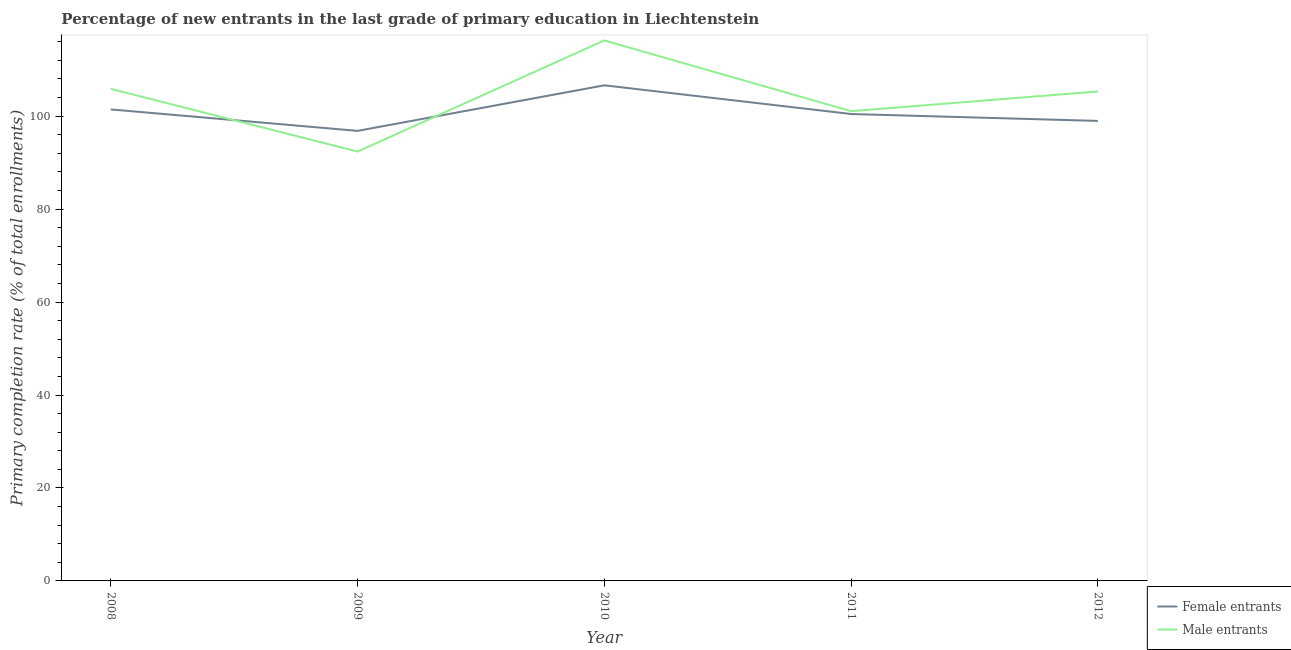What is the primary completion rate of female entrants in 2012?
Offer a very short reply. 98.97. Across all years, what is the maximum primary completion rate of male entrants?
Give a very brief answer. 116.29. Across all years, what is the minimum primary completion rate of male entrants?
Your response must be concise. 92.38. In which year was the primary completion rate of female entrants minimum?
Make the answer very short. 2009. What is the total primary completion rate of female entrants in the graph?
Offer a terse response. 504.35. What is the difference between the primary completion rate of female entrants in 2010 and that in 2011?
Offer a very short reply. 6.17. What is the difference between the primary completion rate of male entrants in 2009 and the primary completion rate of female entrants in 2008?
Offer a terse response. -9.07. What is the average primary completion rate of male entrants per year?
Ensure brevity in your answer.  104.19. In the year 2010, what is the difference between the primary completion rate of female entrants and primary completion rate of male entrants?
Your answer should be compact. -9.66. What is the ratio of the primary completion rate of male entrants in 2008 to that in 2010?
Provide a succinct answer. 0.91. What is the difference between the highest and the second highest primary completion rate of female entrants?
Keep it short and to the point. 5.19. What is the difference between the highest and the lowest primary completion rate of male entrants?
Offer a terse response. 23.92. In how many years, is the primary completion rate of female entrants greater than the average primary completion rate of female entrants taken over all years?
Provide a short and direct response. 2. Is the sum of the primary completion rate of female entrants in 2008 and 2012 greater than the maximum primary completion rate of male entrants across all years?
Your answer should be compact. Yes. Does the primary completion rate of female entrants monotonically increase over the years?
Give a very brief answer. No. How many lines are there?
Make the answer very short. 2. How many years are there in the graph?
Offer a very short reply. 5. What is the difference between two consecutive major ticks on the Y-axis?
Your answer should be very brief. 20. What is the title of the graph?
Your answer should be compact. Percentage of new entrants in the last grade of primary education in Liechtenstein. Does "Pregnant women" appear as one of the legend labels in the graph?
Provide a short and direct response. No. What is the label or title of the X-axis?
Keep it short and to the point. Year. What is the label or title of the Y-axis?
Your response must be concise. Primary completion rate (% of total enrollments). What is the Primary completion rate (% of total enrollments) of Female entrants in 2008?
Provide a short and direct response. 101.45. What is the Primary completion rate (% of total enrollments) in Male entrants in 2008?
Your answer should be compact. 105.88. What is the Primary completion rate (% of total enrollments) in Female entrants in 2009?
Offer a terse response. 96.83. What is the Primary completion rate (% of total enrollments) of Male entrants in 2009?
Ensure brevity in your answer.  92.38. What is the Primary completion rate (% of total enrollments) of Female entrants in 2010?
Keep it short and to the point. 106.64. What is the Primary completion rate (% of total enrollments) in Male entrants in 2010?
Your answer should be very brief. 116.29. What is the Primary completion rate (% of total enrollments) in Female entrants in 2011?
Offer a very short reply. 100.46. What is the Primary completion rate (% of total enrollments) of Male entrants in 2011?
Provide a short and direct response. 101.07. What is the Primary completion rate (% of total enrollments) in Female entrants in 2012?
Your answer should be compact. 98.97. What is the Primary completion rate (% of total enrollments) of Male entrants in 2012?
Provide a succinct answer. 105.31. Across all years, what is the maximum Primary completion rate (% of total enrollments) of Female entrants?
Your answer should be compact. 106.64. Across all years, what is the maximum Primary completion rate (% of total enrollments) of Male entrants?
Provide a succinct answer. 116.29. Across all years, what is the minimum Primary completion rate (% of total enrollments) of Female entrants?
Make the answer very short. 96.83. Across all years, what is the minimum Primary completion rate (% of total enrollments) in Male entrants?
Offer a terse response. 92.38. What is the total Primary completion rate (% of total enrollments) in Female entrants in the graph?
Provide a succinct answer. 504.35. What is the total Primary completion rate (% of total enrollments) in Male entrants in the graph?
Give a very brief answer. 520.93. What is the difference between the Primary completion rate (% of total enrollments) in Female entrants in 2008 and that in 2009?
Your response must be concise. 4.62. What is the difference between the Primary completion rate (% of total enrollments) in Male entrants in 2008 and that in 2009?
Your response must be concise. 13.51. What is the difference between the Primary completion rate (% of total enrollments) of Female entrants in 2008 and that in 2010?
Offer a very short reply. -5.19. What is the difference between the Primary completion rate (% of total enrollments) of Male entrants in 2008 and that in 2010?
Your answer should be very brief. -10.41. What is the difference between the Primary completion rate (% of total enrollments) in Female entrants in 2008 and that in 2011?
Your answer should be very brief. 0.99. What is the difference between the Primary completion rate (% of total enrollments) of Male entrants in 2008 and that in 2011?
Your answer should be very brief. 4.81. What is the difference between the Primary completion rate (% of total enrollments) of Female entrants in 2008 and that in 2012?
Make the answer very short. 2.47. What is the difference between the Primary completion rate (% of total enrollments) of Male entrants in 2008 and that in 2012?
Make the answer very short. 0.57. What is the difference between the Primary completion rate (% of total enrollments) in Female entrants in 2009 and that in 2010?
Keep it short and to the point. -9.8. What is the difference between the Primary completion rate (% of total enrollments) of Male entrants in 2009 and that in 2010?
Offer a terse response. -23.92. What is the difference between the Primary completion rate (% of total enrollments) in Female entrants in 2009 and that in 2011?
Your answer should be very brief. -3.63. What is the difference between the Primary completion rate (% of total enrollments) of Male entrants in 2009 and that in 2011?
Provide a succinct answer. -8.69. What is the difference between the Primary completion rate (% of total enrollments) in Female entrants in 2009 and that in 2012?
Your answer should be very brief. -2.14. What is the difference between the Primary completion rate (% of total enrollments) in Male entrants in 2009 and that in 2012?
Give a very brief answer. -12.94. What is the difference between the Primary completion rate (% of total enrollments) of Female entrants in 2010 and that in 2011?
Keep it short and to the point. 6.17. What is the difference between the Primary completion rate (% of total enrollments) of Male entrants in 2010 and that in 2011?
Ensure brevity in your answer.  15.22. What is the difference between the Primary completion rate (% of total enrollments) in Female entrants in 2010 and that in 2012?
Ensure brevity in your answer.  7.66. What is the difference between the Primary completion rate (% of total enrollments) in Male entrants in 2010 and that in 2012?
Make the answer very short. 10.98. What is the difference between the Primary completion rate (% of total enrollments) of Female entrants in 2011 and that in 2012?
Make the answer very short. 1.49. What is the difference between the Primary completion rate (% of total enrollments) of Male entrants in 2011 and that in 2012?
Ensure brevity in your answer.  -4.24. What is the difference between the Primary completion rate (% of total enrollments) in Female entrants in 2008 and the Primary completion rate (% of total enrollments) in Male entrants in 2009?
Provide a short and direct response. 9.07. What is the difference between the Primary completion rate (% of total enrollments) in Female entrants in 2008 and the Primary completion rate (% of total enrollments) in Male entrants in 2010?
Give a very brief answer. -14.84. What is the difference between the Primary completion rate (% of total enrollments) of Female entrants in 2008 and the Primary completion rate (% of total enrollments) of Male entrants in 2011?
Ensure brevity in your answer.  0.38. What is the difference between the Primary completion rate (% of total enrollments) in Female entrants in 2008 and the Primary completion rate (% of total enrollments) in Male entrants in 2012?
Your answer should be very brief. -3.86. What is the difference between the Primary completion rate (% of total enrollments) in Female entrants in 2009 and the Primary completion rate (% of total enrollments) in Male entrants in 2010?
Provide a succinct answer. -19.46. What is the difference between the Primary completion rate (% of total enrollments) in Female entrants in 2009 and the Primary completion rate (% of total enrollments) in Male entrants in 2011?
Offer a terse response. -4.24. What is the difference between the Primary completion rate (% of total enrollments) in Female entrants in 2009 and the Primary completion rate (% of total enrollments) in Male entrants in 2012?
Offer a terse response. -8.48. What is the difference between the Primary completion rate (% of total enrollments) of Female entrants in 2010 and the Primary completion rate (% of total enrollments) of Male entrants in 2011?
Give a very brief answer. 5.57. What is the difference between the Primary completion rate (% of total enrollments) of Female entrants in 2010 and the Primary completion rate (% of total enrollments) of Male entrants in 2012?
Ensure brevity in your answer.  1.32. What is the difference between the Primary completion rate (% of total enrollments) in Female entrants in 2011 and the Primary completion rate (% of total enrollments) in Male entrants in 2012?
Your response must be concise. -4.85. What is the average Primary completion rate (% of total enrollments) of Female entrants per year?
Your answer should be compact. 100.87. What is the average Primary completion rate (% of total enrollments) of Male entrants per year?
Provide a succinct answer. 104.19. In the year 2008, what is the difference between the Primary completion rate (% of total enrollments) in Female entrants and Primary completion rate (% of total enrollments) in Male entrants?
Ensure brevity in your answer.  -4.43. In the year 2009, what is the difference between the Primary completion rate (% of total enrollments) of Female entrants and Primary completion rate (% of total enrollments) of Male entrants?
Offer a very short reply. 4.46. In the year 2010, what is the difference between the Primary completion rate (% of total enrollments) in Female entrants and Primary completion rate (% of total enrollments) in Male entrants?
Ensure brevity in your answer.  -9.66. In the year 2011, what is the difference between the Primary completion rate (% of total enrollments) in Female entrants and Primary completion rate (% of total enrollments) in Male entrants?
Offer a terse response. -0.61. In the year 2012, what is the difference between the Primary completion rate (% of total enrollments) in Female entrants and Primary completion rate (% of total enrollments) in Male entrants?
Ensure brevity in your answer.  -6.34. What is the ratio of the Primary completion rate (% of total enrollments) in Female entrants in 2008 to that in 2009?
Keep it short and to the point. 1.05. What is the ratio of the Primary completion rate (% of total enrollments) in Male entrants in 2008 to that in 2009?
Offer a very short reply. 1.15. What is the ratio of the Primary completion rate (% of total enrollments) of Female entrants in 2008 to that in 2010?
Give a very brief answer. 0.95. What is the ratio of the Primary completion rate (% of total enrollments) of Male entrants in 2008 to that in 2010?
Your response must be concise. 0.91. What is the ratio of the Primary completion rate (% of total enrollments) of Female entrants in 2008 to that in 2011?
Keep it short and to the point. 1.01. What is the ratio of the Primary completion rate (% of total enrollments) in Male entrants in 2008 to that in 2011?
Make the answer very short. 1.05. What is the ratio of the Primary completion rate (% of total enrollments) in Female entrants in 2008 to that in 2012?
Offer a very short reply. 1.02. What is the ratio of the Primary completion rate (% of total enrollments) in Male entrants in 2008 to that in 2012?
Offer a terse response. 1.01. What is the ratio of the Primary completion rate (% of total enrollments) in Female entrants in 2009 to that in 2010?
Keep it short and to the point. 0.91. What is the ratio of the Primary completion rate (% of total enrollments) of Male entrants in 2009 to that in 2010?
Your response must be concise. 0.79. What is the ratio of the Primary completion rate (% of total enrollments) in Female entrants in 2009 to that in 2011?
Your answer should be very brief. 0.96. What is the ratio of the Primary completion rate (% of total enrollments) in Male entrants in 2009 to that in 2011?
Offer a very short reply. 0.91. What is the ratio of the Primary completion rate (% of total enrollments) in Female entrants in 2009 to that in 2012?
Your response must be concise. 0.98. What is the ratio of the Primary completion rate (% of total enrollments) of Male entrants in 2009 to that in 2012?
Provide a succinct answer. 0.88. What is the ratio of the Primary completion rate (% of total enrollments) of Female entrants in 2010 to that in 2011?
Provide a succinct answer. 1.06. What is the ratio of the Primary completion rate (% of total enrollments) of Male entrants in 2010 to that in 2011?
Give a very brief answer. 1.15. What is the ratio of the Primary completion rate (% of total enrollments) in Female entrants in 2010 to that in 2012?
Your response must be concise. 1.08. What is the ratio of the Primary completion rate (% of total enrollments) in Male entrants in 2010 to that in 2012?
Give a very brief answer. 1.1. What is the ratio of the Primary completion rate (% of total enrollments) in Male entrants in 2011 to that in 2012?
Give a very brief answer. 0.96. What is the difference between the highest and the second highest Primary completion rate (% of total enrollments) in Female entrants?
Offer a very short reply. 5.19. What is the difference between the highest and the second highest Primary completion rate (% of total enrollments) in Male entrants?
Provide a succinct answer. 10.41. What is the difference between the highest and the lowest Primary completion rate (% of total enrollments) of Female entrants?
Your response must be concise. 9.8. What is the difference between the highest and the lowest Primary completion rate (% of total enrollments) in Male entrants?
Provide a succinct answer. 23.92. 